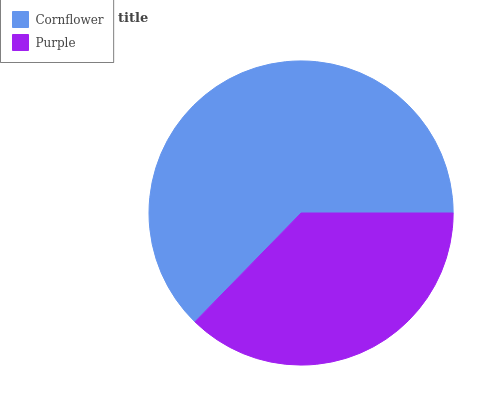Is Purple the minimum?
Answer yes or no. Yes. Is Cornflower the maximum?
Answer yes or no. Yes. Is Purple the maximum?
Answer yes or no. No. Is Cornflower greater than Purple?
Answer yes or no. Yes. Is Purple less than Cornflower?
Answer yes or no. Yes. Is Purple greater than Cornflower?
Answer yes or no. No. Is Cornflower less than Purple?
Answer yes or no. No. Is Cornflower the high median?
Answer yes or no. Yes. Is Purple the low median?
Answer yes or no. Yes. Is Purple the high median?
Answer yes or no. No. Is Cornflower the low median?
Answer yes or no. No. 